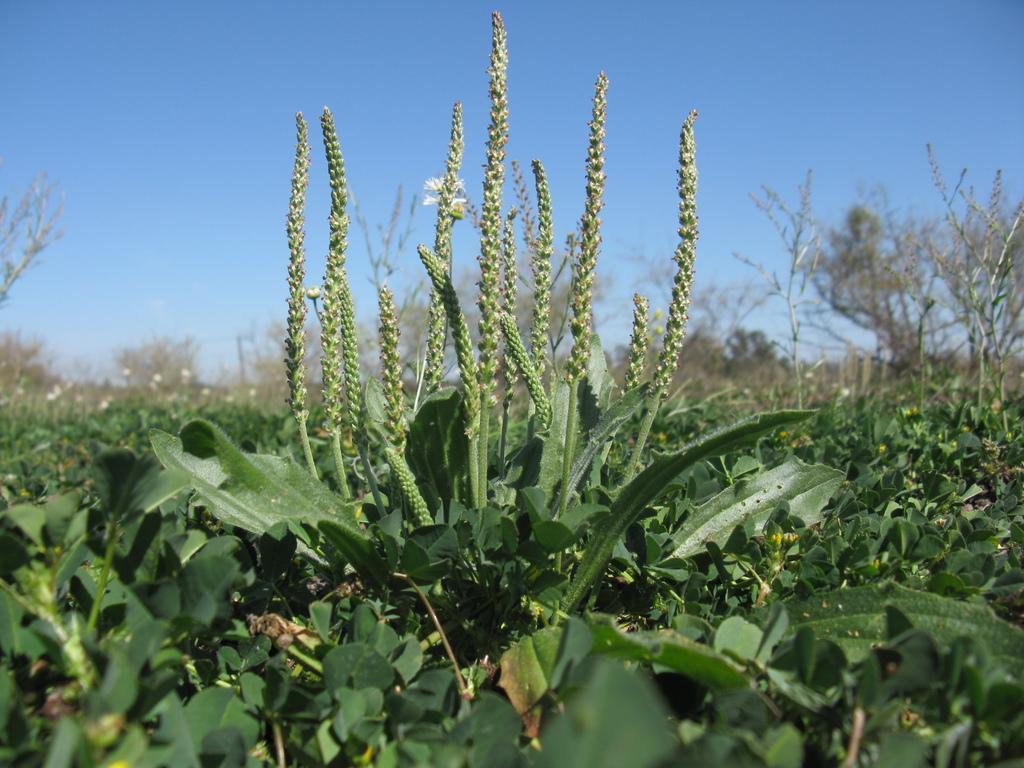Could you give a brief overview of what you see in this image? In this image we can see some plants. At the top of the image there is the sky. 